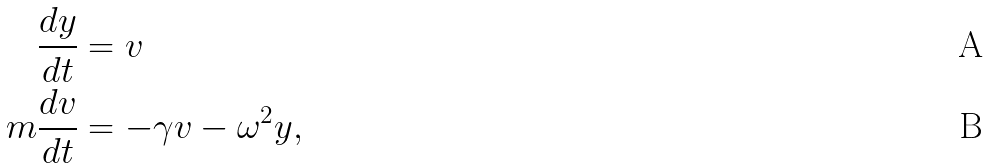<formula> <loc_0><loc_0><loc_500><loc_500>\frac { d y } { d t } & = v \\ m \frac { d v } { d t } & = - \gamma v - \omega ^ { 2 } y ,</formula> 